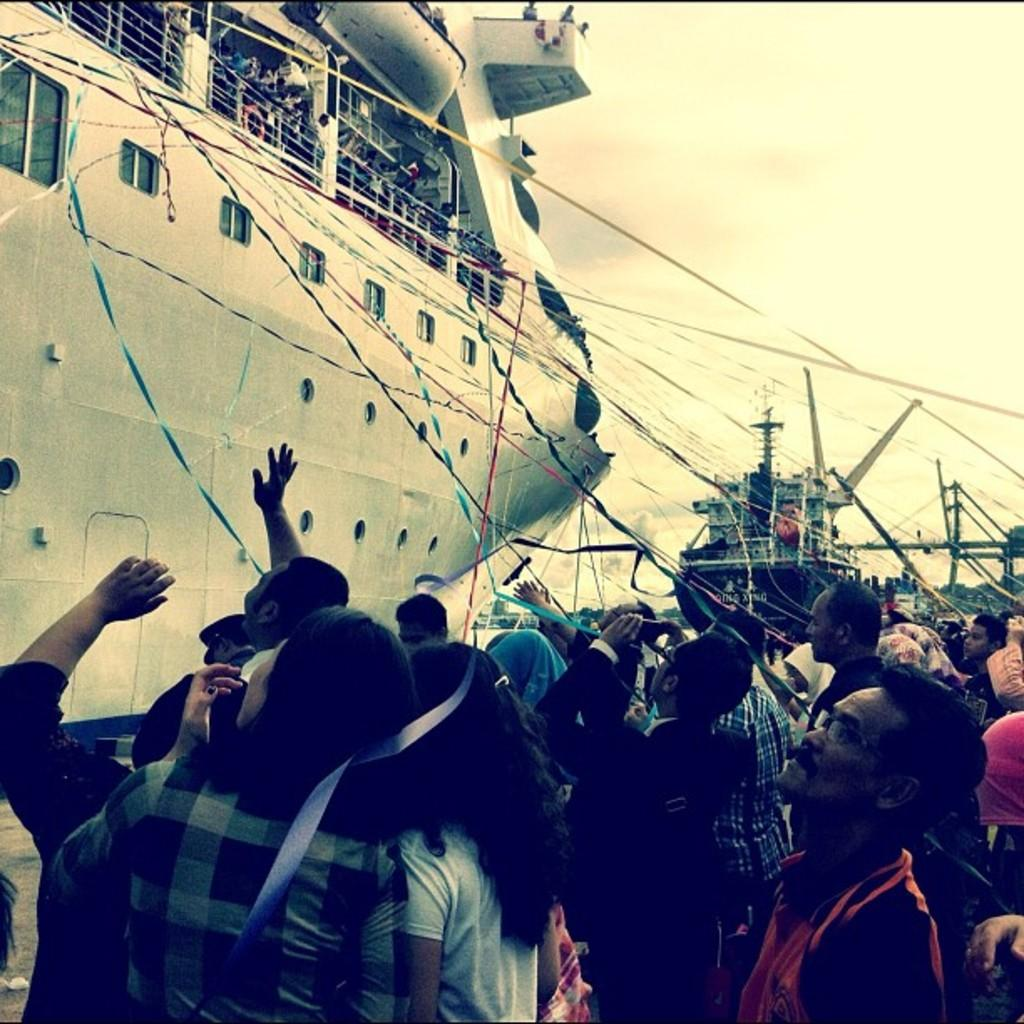What can be seen on the right side of the image? There is a group of people on the right side of the image. What are the people doing in the image? The people are standing and looking at a ship. Where is the ship located in the image? The ship is on the left side of the image. What type of soup is being served in the town depicted in the image? There is no town or soup present in the image; it features a group of people looking at a ship. What show is the group of people attending in the image? There is no show or event mentioned in the image; the people are simply looking at a ship. 